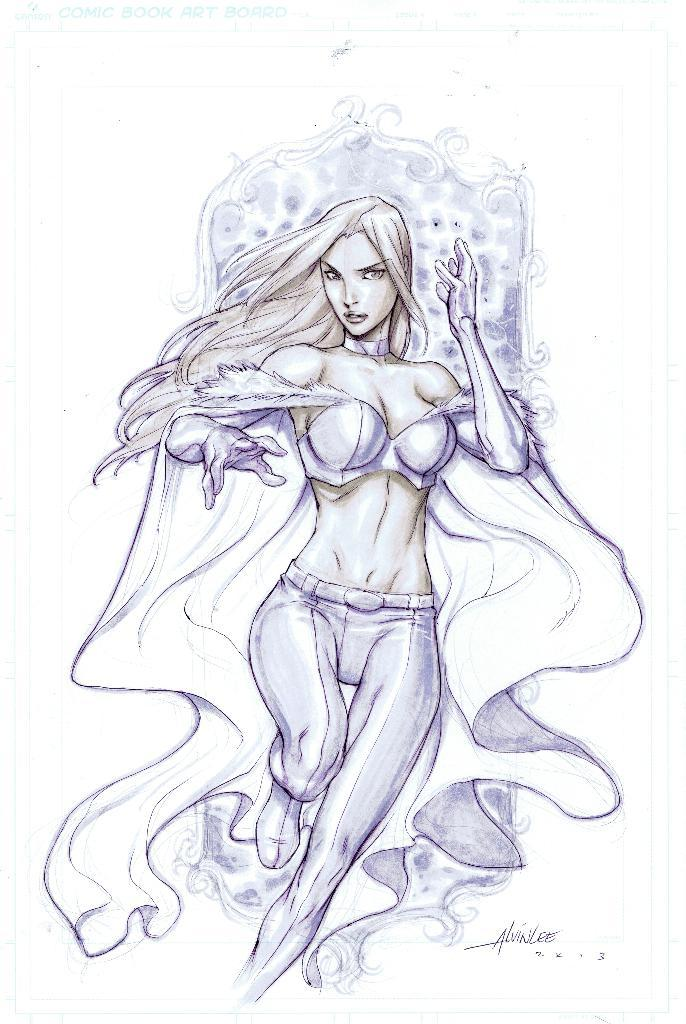What is the main subject of the image? There is an art piece in the image. What does the art piece depict? The art piece depicts a person. What color is the background of the image? The background of the image is white. What type of fruit is being used as a reward for the person in the image? There is no fruit or reward present in the image; it only features an art piece depicting a person with a white background. 